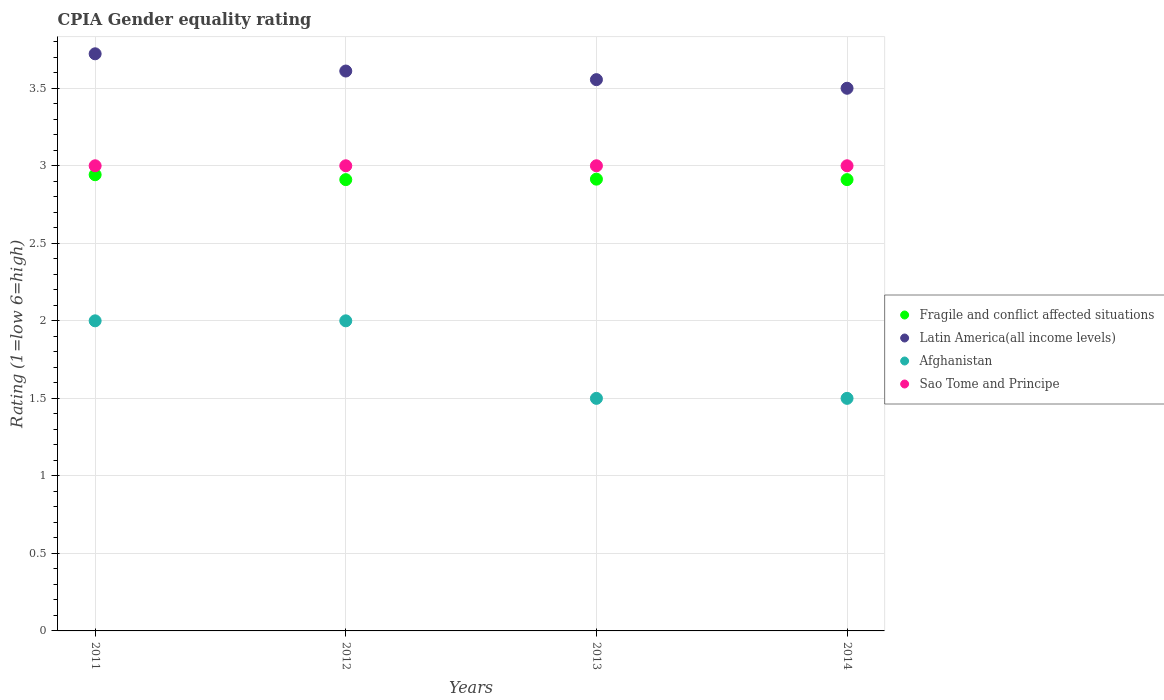Is the number of dotlines equal to the number of legend labels?
Offer a terse response. Yes. What is the CPIA rating in Fragile and conflict affected situations in 2014?
Ensure brevity in your answer.  2.91. Across all years, what is the maximum CPIA rating in Afghanistan?
Keep it short and to the point. 2. Across all years, what is the minimum CPIA rating in Sao Tome and Principe?
Keep it short and to the point. 3. In which year was the CPIA rating in Sao Tome and Principe minimum?
Provide a short and direct response. 2011. What is the total CPIA rating in Fragile and conflict affected situations in the graph?
Provide a short and direct response. 11.68. What is the difference between the CPIA rating in Latin America(all income levels) in 2012 and that in 2014?
Offer a terse response. 0.11. What is the difference between the CPIA rating in Fragile and conflict affected situations in 2014 and the CPIA rating in Latin America(all income levels) in 2012?
Your response must be concise. -0.7. What is the average CPIA rating in Latin America(all income levels) per year?
Provide a succinct answer. 3.6. In the year 2012, what is the difference between the CPIA rating in Latin America(all income levels) and CPIA rating in Sao Tome and Principe?
Your answer should be compact. 0.61. What is the ratio of the CPIA rating in Fragile and conflict affected situations in 2012 to that in 2013?
Offer a very short reply. 1. Is the difference between the CPIA rating in Latin America(all income levels) in 2012 and 2013 greater than the difference between the CPIA rating in Sao Tome and Principe in 2012 and 2013?
Your answer should be compact. Yes. What is the difference between the highest and the second highest CPIA rating in Afghanistan?
Offer a very short reply. 0. What is the difference between the highest and the lowest CPIA rating in Latin America(all income levels)?
Make the answer very short. 0.22. Is the sum of the CPIA rating in Latin America(all income levels) in 2013 and 2014 greater than the maximum CPIA rating in Afghanistan across all years?
Give a very brief answer. Yes. Is it the case that in every year, the sum of the CPIA rating in Afghanistan and CPIA rating in Fragile and conflict affected situations  is greater than the sum of CPIA rating in Latin America(all income levels) and CPIA rating in Sao Tome and Principe?
Make the answer very short. No. Is it the case that in every year, the sum of the CPIA rating in Sao Tome and Principe and CPIA rating in Afghanistan  is greater than the CPIA rating in Fragile and conflict affected situations?
Provide a succinct answer. Yes. Is the CPIA rating in Latin America(all income levels) strictly greater than the CPIA rating in Afghanistan over the years?
Your answer should be very brief. Yes. How many years are there in the graph?
Ensure brevity in your answer.  4. What is the difference between two consecutive major ticks on the Y-axis?
Give a very brief answer. 0.5. Are the values on the major ticks of Y-axis written in scientific E-notation?
Your answer should be very brief. No. Does the graph contain any zero values?
Provide a succinct answer. No. Where does the legend appear in the graph?
Keep it short and to the point. Center right. What is the title of the graph?
Keep it short and to the point. CPIA Gender equality rating. Does "Mongolia" appear as one of the legend labels in the graph?
Provide a succinct answer. No. What is the label or title of the Y-axis?
Your answer should be compact. Rating (1=low 6=high). What is the Rating (1=low 6=high) of Fragile and conflict affected situations in 2011?
Offer a very short reply. 2.94. What is the Rating (1=low 6=high) in Latin America(all income levels) in 2011?
Make the answer very short. 3.72. What is the Rating (1=low 6=high) of Afghanistan in 2011?
Your response must be concise. 2. What is the Rating (1=low 6=high) of Fragile and conflict affected situations in 2012?
Make the answer very short. 2.91. What is the Rating (1=low 6=high) in Latin America(all income levels) in 2012?
Provide a short and direct response. 3.61. What is the Rating (1=low 6=high) of Sao Tome and Principe in 2012?
Offer a very short reply. 3. What is the Rating (1=low 6=high) of Fragile and conflict affected situations in 2013?
Provide a succinct answer. 2.91. What is the Rating (1=low 6=high) in Latin America(all income levels) in 2013?
Give a very brief answer. 3.56. What is the Rating (1=low 6=high) of Afghanistan in 2013?
Provide a short and direct response. 1.5. What is the Rating (1=low 6=high) in Fragile and conflict affected situations in 2014?
Provide a succinct answer. 2.91. What is the Rating (1=low 6=high) of Latin America(all income levels) in 2014?
Ensure brevity in your answer.  3.5. What is the Rating (1=low 6=high) in Afghanistan in 2014?
Your answer should be very brief. 1.5. What is the Rating (1=low 6=high) in Sao Tome and Principe in 2014?
Ensure brevity in your answer.  3. Across all years, what is the maximum Rating (1=low 6=high) of Fragile and conflict affected situations?
Make the answer very short. 2.94. Across all years, what is the maximum Rating (1=low 6=high) in Latin America(all income levels)?
Make the answer very short. 3.72. Across all years, what is the maximum Rating (1=low 6=high) of Afghanistan?
Provide a short and direct response. 2. Across all years, what is the minimum Rating (1=low 6=high) of Fragile and conflict affected situations?
Offer a terse response. 2.91. Across all years, what is the minimum Rating (1=low 6=high) of Latin America(all income levels)?
Ensure brevity in your answer.  3.5. What is the total Rating (1=low 6=high) of Fragile and conflict affected situations in the graph?
Keep it short and to the point. 11.68. What is the total Rating (1=low 6=high) in Latin America(all income levels) in the graph?
Your response must be concise. 14.39. What is the total Rating (1=low 6=high) in Sao Tome and Principe in the graph?
Your response must be concise. 12. What is the difference between the Rating (1=low 6=high) in Fragile and conflict affected situations in 2011 and that in 2012?
Give a very brief answer. 0.03. What is the difference between the Rating (1=low 6=high) in Latin America(all income levels) in 2011 and that in 2012?
Offer a very short reply. 0.11. What is the difference between the Rating (1=low 6=high) of Afghanistan in 2011 and that in 2012?
Ensure brevity in your answer.  0. What is the difference between the Rating (1=low 6=high) of Fragile and conflict affected situations in 2011 and that in 2013?
Provide a succinct answer. 0.03. What is the difference between the Rating (1=low 6=high) in Latin America(all income levels) in 2011 and that in 2013?
Offer a very short reply. 0.17. What is the difference between the Rating (1=low 6=high) in Sao Tome and Principe in 2011 and that in 2013?
Make the answer very short. 0. What is the difference between the Rating (1=low 6=high) of Fragile and conflict affected situations in 2011 and that in 2014?
Offer a terse response. 0.03. What is the difference between the Rating (1=low 6=high) of Latin America(all income levels) in 2011 and that in 2014?
Provide a succinct answer. 0.22. What is the difference between the Rating (1=low 6=high) in Sao Tome and Principe in 2011 and that in 2014?
Keep it short and to the point. 0. What is the difference between the Rating (1=low 6=high) in Fragile and conflict affected situations in 2012 and that in 2013?
Your answer should be compact. -0. What is the difference between the Rating (1=low 6=high) in Latin America(all income levels) in 2012 and that in 2013?
Provide a short and direct response. 0.06. What is the difference between the Rating (1=low 6=high) of Afghanistan in 2012 and that in 2013?
Your answer should be very brief. 0.5. What is the difference between the Rating (1=low 6=high) in Fragile and conflict affected situations in 2012 and that in 2014?
Keep it short and to the point. 0. What is the difference between the Rating (1=low 6=high) in Latin America(all income levels) in 2012 and that in 2014?
Provide a succinct answer. 0.11. What is the difference between the Rating (1=low 6=high) in Afghanistan in 2012 and that in 2014?
Make the answer very short. 0.5. What is the difference between the Rating (1=low 6=high) in Sao Tome and Principe in 2012 and that in 2014?
Offer a terse response. 0. What is the difference between the Rating (1=low 6=high) in Fragile and conflict affected situations in 2013 and that in 2014?
Your response must be concise. 0. What is the difference between the Rating (1=low 6=high) in Latin America(all income levels) in 2013 and that in 2014?
Ensure brevity in your answer.  0.06. What is the difference between the Rating (1=low 6=high) in Fragile and conflict affected situations in 2011 and the Rating (1=low 6=high) in Latin America(all income levels) in 2012?
Provide a succinct answer. -0.67. What is the difference between the Rating (1=low 6=high) of Fragile and conflict affected situations in 2011 and the Rating (1=low 6=high) of Afghanistan in 2012?
Provide a succinct answer. 0.94. What is the difference between the Rating (1=low 6=high) in Fragile and conflict affected situations in 2011 and the Rating (1=low 6=high) in Sao Tome and Principe in 2012?
Keep it short and to the point. -0.06. What is the difference between the Rating (1=low 6=high) in Latin America(all income levels) in 2011 and the Rating (1=low 6=high) in Afghanistan in 2012?
Offer a terse response. 1.72. What is the difference between the Rating (1=low 6=high) in Latin America(all income levels) in 2011 and the Rating (1=low 6=high) in Sao Tome and Principe in 2012?
Your answer should be very brief. 0.72. What is the difference between the Rating (1=low 6=high) of Fragile and conflict affected situations in 2011 and the Rating (1=low 6=high) of Latin America(all income levels) in 2013?
Your answer should be compact. -0.61. What is the difference between the Rating (1=low 6=high) of Fragile and conflict affected situations in 2011 and the Rating (1=low 6=high) of Afghanistan in 2013?
Offer a very short reply. 1.44. What is the difference between the Rating (1=low 6=high) in Fragile and conflict affected situations in 2011 and the Rating (1=low 6=high) in Sao Tome and Principe in 2013?
Offer a terse response. -0.06. What is the difference between the Rating (1=low 6=high) of Latin America(all income levels) in 2011 and the Rating (1=low 6=high) of Afghanistan in 2013?
Provide a succinct answer. 2.22. What is the difference between the Rating (1=low 6=high) of Latin America(all income levels) in 2011 and the Rating (1=low 6=high) of Sao Tome and Principe in 2013?
Provide a short and direct response. 0.72. What is the difference between the Rating (1=low 6=high) in Afghanistan in 2011 and the Rating (1=low 6=high) in Sao Tome and Principe in 2013?
Keep it short and to the point. -1. What is the difference between the Rating (1=low 6=high) of Fragile and conflict affected situations in 2011 and the Rating (1=low 6=high) of Latin America(all income levels) in 2014?
Provide a short and direct response. -0.56. What is the difference between the Rating (1=low 6=high) in Fragile and conflict affected situations in 2011 and the Rating (1=low 6=high) in Afghanistan in 2014?
Keep it short and to the point. 1.44. What is the difference between the Rating (1=low 6=high) of Fragile and conflict affected situations in 2011 and the Rating (1=low 6=high) of Sao Tome and Principe in 2014?
Your answer should be compact. -0.06. What is the difference between the Rating (1=low 6=high) in Latin America(all income levels) in 2011 and the Rating (1=low 6=high) in Afghanistan in 2014?
Your response must be concise. 2.22. What is the difference between the Rating (1=low 6=high) of Latin America(all income levels) in 2011 and the Rating (1=low 6=high) of Sao Tome and Principe in 2014?
Offer a terse response. 0.72. What is the difference between the Rating (1=low 6=high) of Fragile and conflict affected situations in 2012 and the Rating (1=low 6=high) of Latin America(all income levels) in 2013?
Your answer should be compact. -0.64. What is the difference between the Rating (1=low 6=high) of Fragile and conflict affected situations in 2012 and the Rating (1=low 6=high) of Afghanistan in 2013?
Give a very brief answer. 1.41. What is the difference between the Rating (1=low 6=high) of Fragile and conflict affected situations in 2012 and the Rating (1=low 6=high) of Sao Tome and Principe in 2013?
Your answer should be compact. -0.09. What is the difference between the Rating (1=low 6=high) in Latin America(all income levels) in 2012 and the Rating (1=low 6=high) in Afghanistan in 2013?
Offer a very short reply. 2.11. What is the difference between the Rating (1=low 6=high) in Latin America(all income levels) in 2012 and the Rating (1=low 6=high) in Sao Tome and Principe in 2013?
Offer a very short reply. 0.61. What is the difference between the Rating (1=low 6=high) of Fragile and conflict affected situations in 2012 and the Rating (1=low 6=high) of Latin America(all income levels) in 2014?
Offer a very short reply. -0.59. What is the difference between the Rating (1=low 6=high) of Fragile and conflict affected situations in 2012 and the Rating (1=low 6=high) of Afghanistan in 2014?
Give a very brief answer. 1.41. What is the difference between the Rating (1=low 6=high) of Fragile and conflict affected situations in 2012 and the Rating (1=low 6=high) of Sao Tome and Principe in 2014?
Make the answer very short. -0.09. What is the difference between the Rating (1=low 6=high) of Latin America(all income levels) in 2012 and the Rating (1=low 6=high) of Afghanistan in 2014?
Provide a short and direct response. 2.11. What is the difference between the Rating (1=low 6=high) of Latin America(all income levels) in 2012 and the Rating (1=low 6=high) of Sao Tome and Principe in 2014?
Offer a very short reply. 0.61. What is the difference between the Rating (1=low 6=high) in Afghanistan in 2012 and the Rating (1=low 6=high) in Sao Tome and Principe in 2014?
Provide a succinct answer. -1. What is the difference between the Rating (1=low 6=high) in Fragile and conflict affected situations in 2013 and the Rating (1=low 6=high) in Latin America(all income levels) in 2014?
Provide a succinct answer. -0.59. What is the difference between the Rating (1=low 6=high) of Fragile and conflict affected situations in 2013 and the Rating (1=low 6=high) of Afghanistan in 2014?
Your response must be concise. 1.41. What is the difference between the Rating (1=low 6=high) of Fragile and conflict affected situations in 2013 and the Rating (1=low 6=high) of Sao Tome and Principe in 2014?
Ensure brevity in your answer.  -0.09. What is the difference between the Rating (1=low 6=high) of Latin America(all income levels) in 2013 and the Rating (1=low 6=high) of Afghanistan in 2014?
Offer a terse response. 2.06. What is the difference between the Rating (1=low 6=high) in Latin America(all income levels) in 2013 and the Rating (1=low 6=high) in Sao Tome and Principe in 2014?
Give a very brief answer. 0.56. What is the difference between the Rating (1=low 6=high) in Afghanistan in 2013 and the Rating (1=low 6=high) in Sao Tome and Principe in 2014?
Provide a short and direct response. -1.5. What is the average Rating (1=low 6=high) of Fragile and conflict affected situations per year?
Provide a succinct answer. 2.92. What is the average Rating (1=low 6=high) of Latin America(all income levels) per year?
Provide a succinct answer. 3.6. In the year 2011, what is the difference between the Rating (1=low 6=high) in Fragile and conflict affected situations and Rating (1=low 6=high) in Latin America(all income levels)?
Ensure brevity in your answer.  -0.78. In the year 2011, what is the difference between the Rating (1=low 6=high) in Fragile and conflict affected situations and Rating (1=low 6=high) in Afghanistan?
Offer a very short reply. 0.94. In the year 2011, what is the difference between the Rating (1=low 6=high) in Fragile and conflict affected situations and Rating (1=low 6=high) in Sao Tome and Principe?
Offer a very short reply. -0.06. In the year 2011, what is the difference between the Rating (1=low 6=high) of Latin America(all income levels) and Rating (1=low 6=high) of Afghanistan?
Keep it short and to the point. 1.72. In the year 2011, what is the difference between the Rating (1=low 6=high) of Latin America(all income levels) and Rating (1=low 6=high) of Sao Tome and Principe?
Your answer should be compact. 0.72. In the year 2012, what is the difference between the Rating (1=low 6=high) in Fragile and conflict affected situations and Rating (1=low 6=high) in Latin America(all income levels)?
Keep it short and to the point. -0.7. In the year 2012, what is the difference between the Rating (1=low 6=high) of Fragile and conflict affected situations and Rating (1=low 6=high) of Afghanistan?
Provide a succinct answer. 0.91. In the year 2012, what is the difference between the Rating (1=low 6=high) of Fragile and conflict affected situations and Rating (1=low 6=high) of Sao Tome and Principe?
Provide a short and direct response. -0.09. In the year 2012, what is the difference between the Rating (1=low 6=high) in Latin America(all income levels) and Rating (1=low 6=high) in Afghanistan?
Provide a short and direct response. 1.61. In the year 2012, what is the difference between the Rating (1=low 6=high) of Latin America(all income levels) and Rating (1=low 6=high) of Sao Tome and Principe?
Make the answer very short. 0.61. In the year 2013, what is the difference between the Rating (1=low 6=high) in Fragile and conflict affected situations and Rating (1=low 6=high) in Latin America(all income levels)?
Ensure brevity in your answer.  -0.64. In the year 2013, what is the difference between the Rating (1=low 6=high) in Fragile and conflict affected situations and Rating (1=low 6=high) in Afghanistan?
Your answer should be compact. 1.41. In the year 2013, what is the difference between the Rating (1=low 6=high) in Fragile and conflict affected situations and Rating (1=low 6=high) in Sao Tome and Principe?
Ensure brevity in your answer.  -0.09. In the year 2013, what is the difference between the Rating (1=low 6=high) in Latin America(all income levels) and Rating (1=low 6=high) in Afghanistan?
Provide a succinct answer. 2.06. In the year 2013, what is the difference between the Rating (1=low 6=high) of Latin America(all income levels) and Rating (1=low 6=high) of Sao Tome and Principe?
Make the answer very short. 0.56. In the year 2014, what is the difference between the Rating (1=low 6=high) in Fragile and conflict affected situations and Rating (1=low 6=high) in Latin America(all income levels)?
Offer a terse response. -0.59. In the year 2014, what is the difference between the Rating (1=low 6=high) in Fragile and conflict affected situations and Rating (1=low 6=high) in Afghanistan?
Give a very brief answer. 1.41. In the year 2014, what is the difference between the Rating (1=low 6=high) in Fragile and conflict affected situations and Rating (1=low 6=high) in Sao Tome and Principe?
Your answer should be compact. -0.09. In the year 2014, what is the difference between the Rating (1=low 6=high) of Afghanistan and Rating (1=low 6=high) of Sao Tome and Principe?
Provide a short and direct response. -1.5. What is the ratio of the Rating (1=low 6=high) of Fragile and conflict affected situations in 2011 to that in 2012?
Offer a very short reply. 1.01. What is the ratio of the Rating (1=low 6=high) of Latin America(all income levels) in 2011 to that in 2012?
Give a very brief answer. 1.03. What is the ratio of the Rating (1=low 6=high) of Sao Tome and Principe in 2011 to that in 2012?
Ensure brevity in your answer.  1. What is the ratio of the Rating (1=low 6=high) in Fragile and conflict affected situations in 2011 to that in 2013?
Keep it short and to the point. 1.01. What is the ratio of the Rating (1=low 6=high) in Latin America(all income levels) in 2011 to that in 2013?
Make the answer very short. 1.05. What is the ratio of the Rating (1=low 6=high) of Afghanistan in 2011 to that in 2013?
Give a very brief answer. 1.33. What is the ratio of the Rating (1=low 6=high) of Sao Tome and Principe in 2011 to that in 2013?
Your answer should be very brief. 1. What is the ratio of the Rating (1=low 6=high) of Fragile and conflict affected situations in 2011 to that in 2014?
Offer a terse response. 1.01. What is the ratio of the Rating (1=low 6=high) of Latin America(all income levels) in 2011 to that in 2014?
Offer a terse response. 1.06. What is the ratio of the Rating (1=low 6=high) in Latin America(all income levels) in 2012 to that in 2013?
Offer a very short reply. 1.02. What is the ratio of the Rating (1=low 6=high) in Fragile and conflict affected situations in 2012 to that in 2014?
Your answer should be compact. 1. What is the ratio of the Rating (1=low 6=high) of Latin America(all income levels) in 2012 to that in 2014?
Make the answer very short. 1.03. What is the ratio of the Rating (1=low 6=high) of Fragile and conflict affected situations in 2013 to that in 2014?
Provide a succinct answer. 1. What is the ratio of the Rating (1=low 6=high) of Latin America(all income levels) in 2013 to that in 2014?
Ensure brevity in your answer.  1.02. What is the difference between the highest and the second highest Rating (1=low 6=high) of Fragile and conflict affected situations?
Your response must be concise. 0.03. What is the difference between the highest and the second highest Rating (1=low 6=high) in Afghanistan?
Offer a very short reply. 0. What is the difference between the highest and the second highest Rating (1=low 6=high) of Sao Tome and Principe?
Provide a succinct answer. 0. What is the difference between the highest and the lowest Rating (1=low 6=high) in Fragile and conflict affected situations?
Give a very brief answer. 0.03. What is the difference between the highest and the lowest Rating (1=low 6=high) of Latin America(all income levels)?
Offer a terse response. 0.22. 